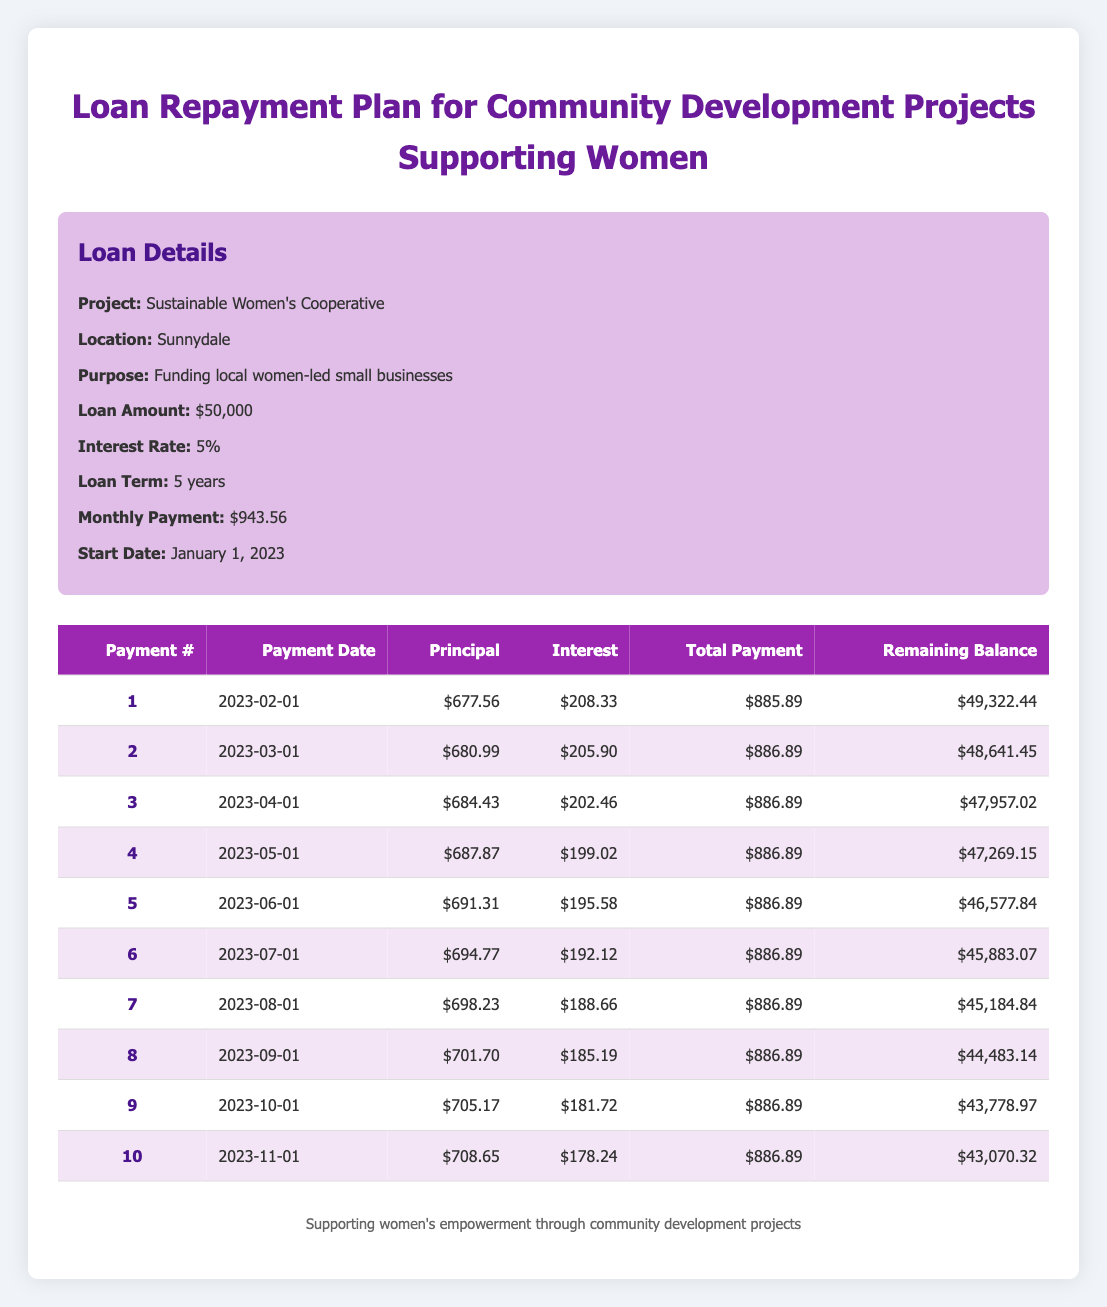What is the monthly payment for the loan? The monthly payment for the loan is directly stated in the loan details section, which shows a monthly payment of $943.56
Answer: 943.56 What is the interest payment for the first month? The interest payment for the first month is listed in the amortization schedule, which shows it as $208.33
Answer: 208.33 What is the remaining balance after the fifth payment? The remaining balance after the fifth payment can be found in the amortization schedule after the fifth row, which shows it as $46,577.84
Answer: 46,577.84 How much principal is paid off in the first three payments combined? To find this, add the principal payments for the first three payments: 677.56 + 680.99 + 684.43 = 2042.98
Answer: 2042.98 Is the total payment for the second month greater than the total payment for the first month? The total payment for the first month is $885.89, and for the second month is $886.89. Since $886.89 > $885.89, the statement is true
Answer: Yes What is the total interest paid over the first quarter? To find this, sum the interest payments for the first three months: 208.33 + 205.90 + 202.46 = 616.69
Answer: 616.69 What is the difference in total payments between the first and tenth months? For the first month, the total payment is $885.89, and for the tenth month, it is $886.89. The difference is $886.89 - $885.89 = $1.00
Answer: 1.00 What is the average principal payment for the first five months? First, sum the principal payments from the first five payments: 677.56 + 680.99 + 684.43 + 687.87 + 691.31 = 3,522.16. Divide this by 5 to get the average: 3,522.16 / 5 = 704.432
Answer: 704.43 What is the balance after the seventh payment? The balance after the seventh payment is found in the amortization table for payment number seven, which shows a remaining balance of $45,184.84
Answer: 45,184.84 